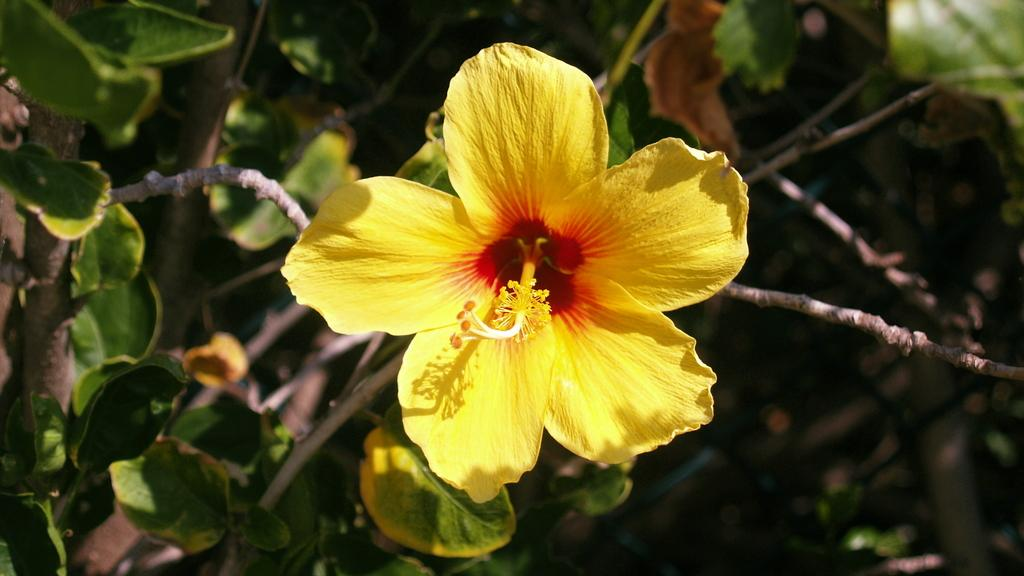What type of plant can be seen in the image? There is a flower in the image. What parts of the plant are visible besides the flower? There are stems and leaves in the image. How would you describe the background of the image? The background of the image is blurry. What type of cow can be seen grazing in the background of the image? There is no cow present in the image; it only features a flower, stems, and leaves. 